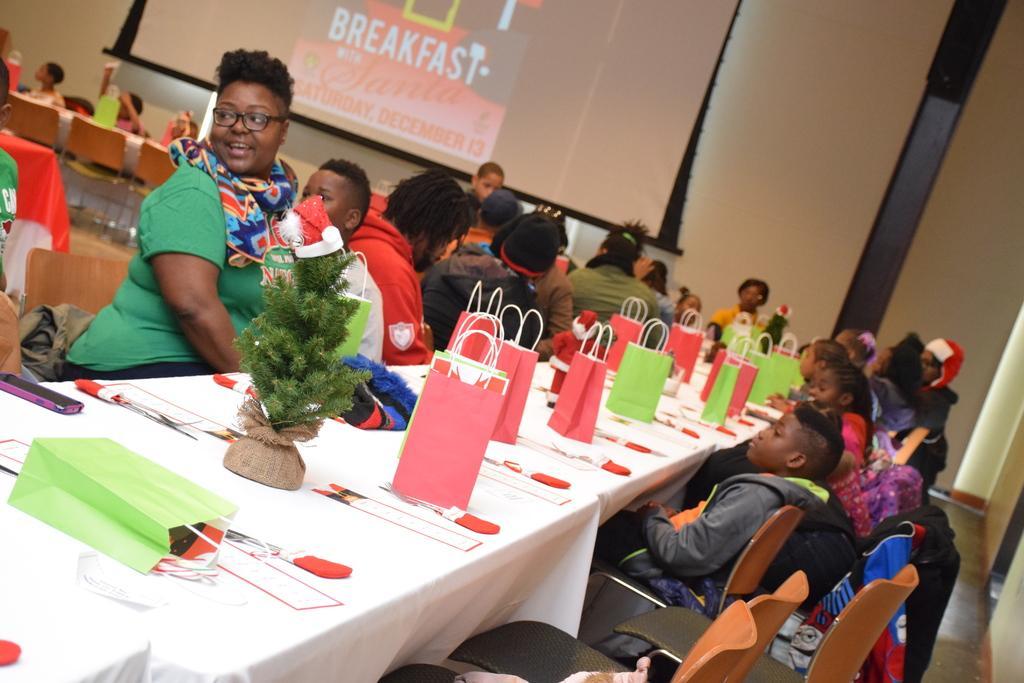Please provide a concise description of this image. In this image there are group of people sitting on the chair. On the table there is a bag,flower pot and a mobile on the table. At the background there is a screen on the wall. 